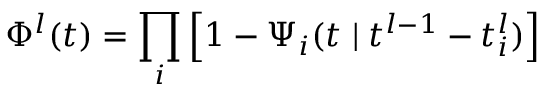<formula> <loc_0><loc_0><loc_500><loc_500>\Phi ^ { l } ( t ) = \prod _ { i } \left [ 1 - \Psi _ { i } ( t { \, | \, } t ^ { l - 1 } - t _ { i } ^ { l } ) \right ]</formula> 